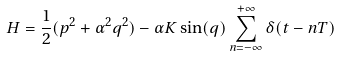Convert formula to latex. <formula><loc_0><loc_0><loc_500><loc_500>H = \frac { 1 } { 2 } ( p ^ { 2 } + \alpha ^ { 2 } q ^ { 2 } ) - \alpha K \sin ( q ) \sum _ { n = - \infty } ^ { + \infty } \delta ( t - n T )</formula> 